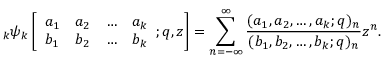<formula> <loc_0><loc_0><loc_500><loc_500>\, _ { k } \psi _ { k } \left [ { \begin{array} { l l l l } { a _ { 1 } } & { a _ { 2 } } & { \dots } & { a _ { k } } \\ { b _ { 1 } } & { b _ { 2 } } & { \dots } & { b _ { k } } \end{array} } ; q , z \right ] = \sum _ { n = - \infty } ^ { \infty } { \frac { ( a _ { 1 } , a _ { 2 } , \dots , a _ { k } ; q ) _ { n } } { ( b _ { 1 } , b _ { 2 } , \dots , b _ { k } ; q ) _ { n } } } z ^ { n } .</formula> 